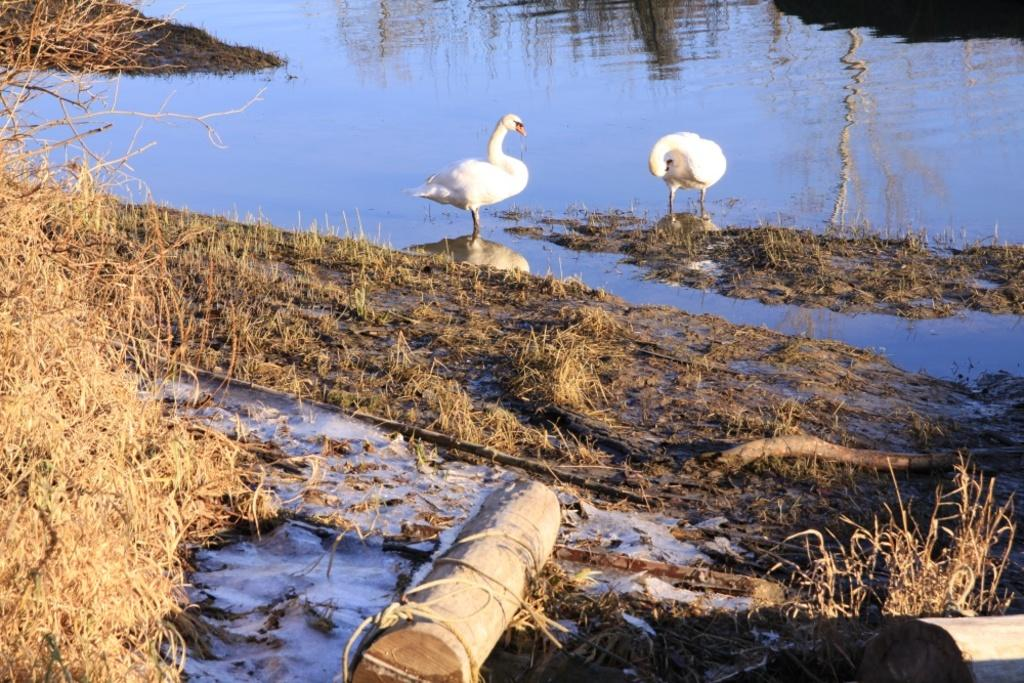What type of environment is shown in the image? The image is an outside view. What natural element can be seen in the image? There is water visible in the image. How many birds are present in the image? There are two white color birds in the image. What are the birds standing on? The birds are standing on rocks. What type of vegetation is at the bottom of the image? There is grass at the bottom of the image. What other objects can be seen at the bottom of the image? There are sticks at the bottom of the image. What type of bead is being used to rate the image? There is no bead or rating system present in the image. 